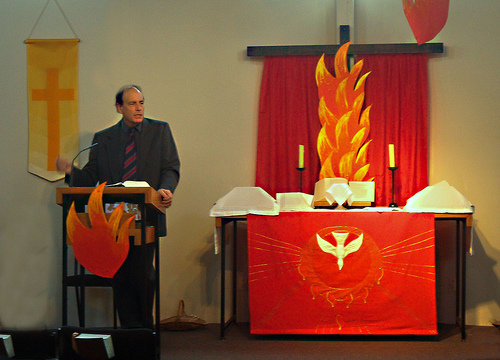<image>
Can you confirm if the fire is behind the man? No. The fire is not behind the man. From this viewpoint, the fire appears to be positioned elsewhere in the scene. Is there a curtain above the table? Yes. The curtain is positioned above the table in the vertical space, higher up in the scene. 